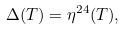Convert formula to latex. <formula><loc_0><loc_0><loc_500><loc_500>\Delta ( T ) = \eta ^ { 2 4 } ( T ) ,</formula> 